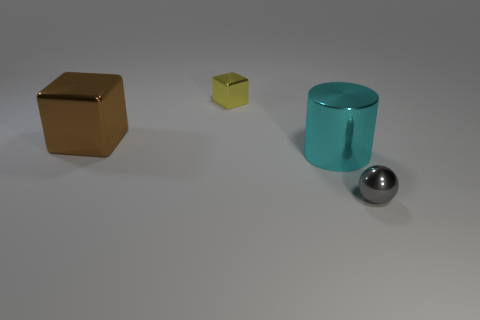How many other things are the same shape as the yellow thing?
Your answer should be very brief. 1. Are there fewer big things than metallic things?
Give a very brief answer. Yes. There is a thing that is on the left side of the small metal ball and in front of the brown metal thing; what is its size?
Your answer should be very brief. Large. What size is the metallic cube that is to the right of the big shiny thing behind the big shiny thing right of the brown metallic cube?
Your answer should be very brief. Small. What size is the yellow object?
Your answer should be compact. Small. Are there any cyan cylinders that are in front of the small shiny thing that is behind the tiny thing right of the yellow thing?
Give a very brief answer. Yes. How many big objects are either gray metallic spheres or purple metallic cylinders?
Offer a very short reply. 0. Does the metal block on the right side of the brown block have the same size as the ball?
Make the answer very short. Yes. There is a small thing behind the tiny metal object in front of the small yellow shiny block that is left of the metal cylinder; what color is it?
Your response must be concise. Yellow. The tiny cube has what color?
Provide a succinct answer. Yellow. 